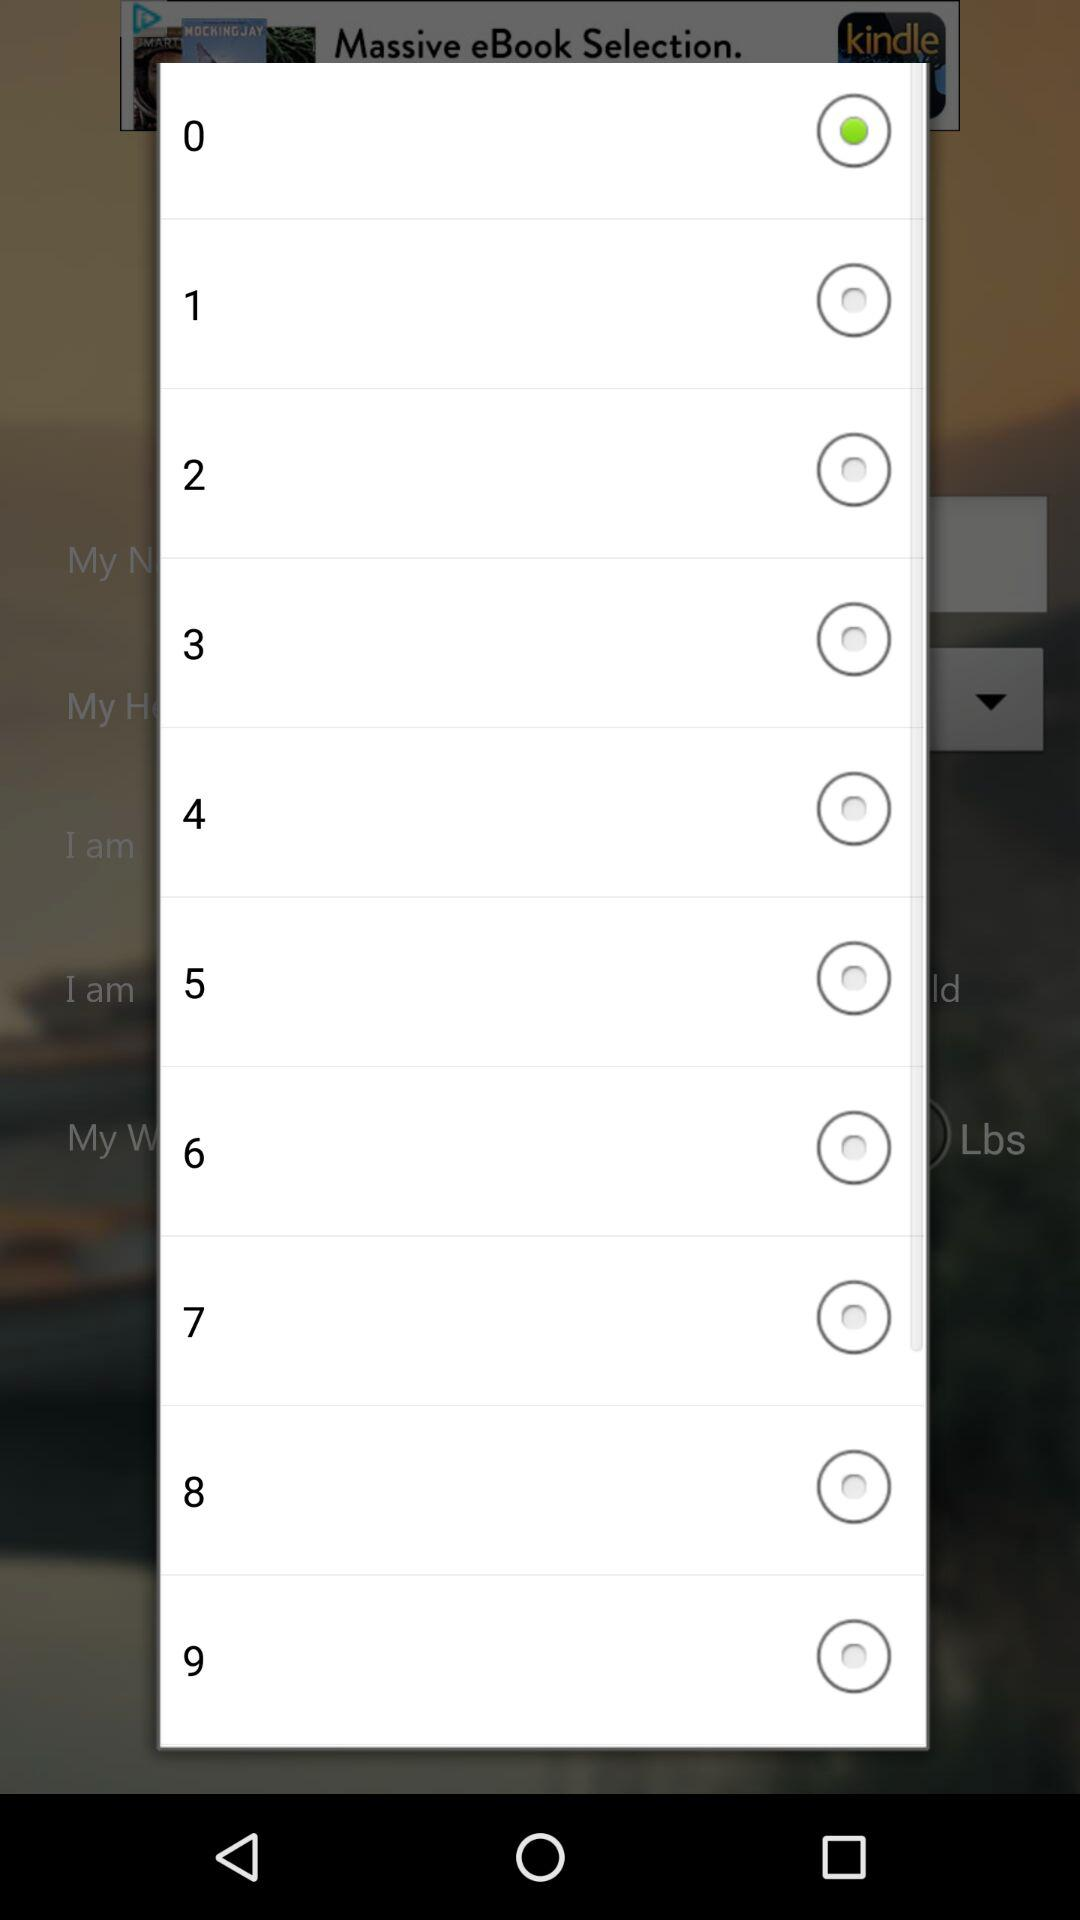What is the selected option? The selected option is 0. 